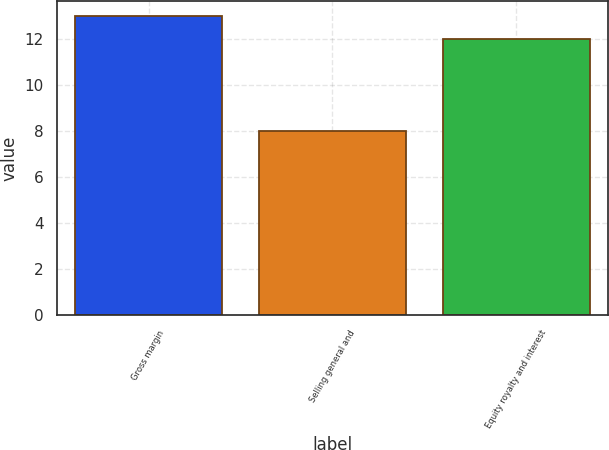Convert chart. <chart><loc_0><loc_0><loc_500><loc_500><bar_chart><fcel>Gross margin<fcel>Selling general and<fcel>Equity royalty and interest<nl><fcel>13<fcel>8<fcel>12<nl></chart> 